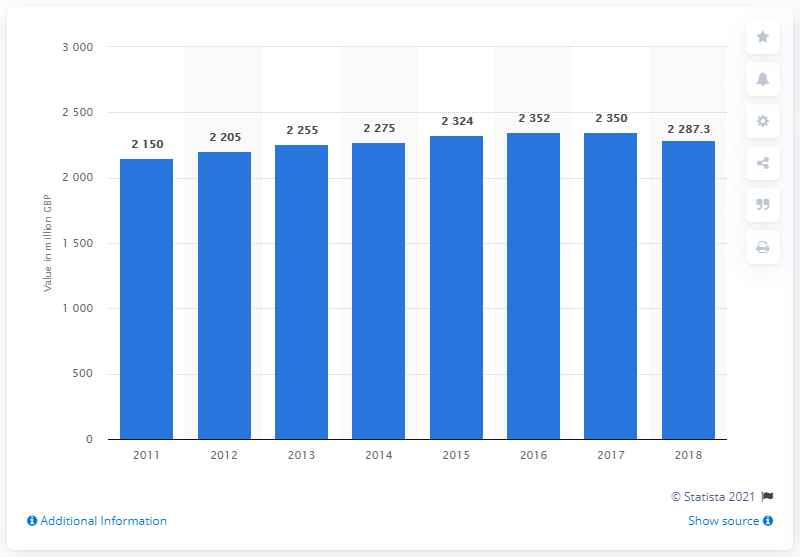Point out several critical features in this image. In 2018, the gross transaction value (GTV) of Debenhams in the UK was 2275. 